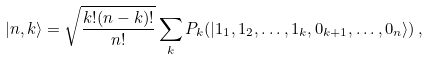Convert formula to latex. <formula><loc_0><loc_0><loc_500><loc_500>| n , k \rangle = \sqrt { \frac { k ! ( n - k ) ! } { n ! } } \sum _ { k } P _ { k } ( | 1 _ { 1 } , 1 _ { 2 } , \dots , 1 _ { k } , 0 _ { k + 1 } , \dots , 0 _ { n } \rangle ) \, ,</formula> 